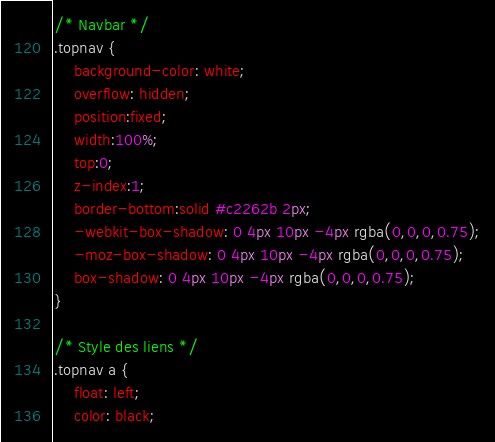<code> <loc_0><loc_0><loc_500><loc_500><_CSS_>/* Navbar */
.topnav {
	background-color: white;
	overflow: hidden;
	position:fixed;
	width:100%;
	top:0;
	z-index:1;
	border-bottom:solid #c2262b 2px;
	-webkit-box-shadow: 0 4px 10px -4px rgba(0,0,0,0.75);
	-moz-box-shadow: 0 4px 10px -4px rgba(0,0,0,0.75);
	box-shadow: 0 4px 10px -4px rgba(0,0,0,0.75);
}

/* Style des liens */
.topnav a {
	float: left;
	color: black;</code> 